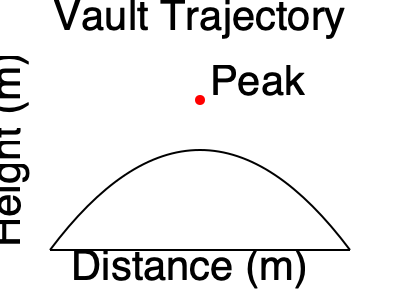As a gymnastics coach, you're analyzing the optimal trajectory for Candice Richer's vault. Assuming the vault follows a parabolic path and neglecting air resistance, what is the initial velocity angle θ (in degrees) that maximizes the horizontal distance traveled if the initial velocity magnitude is 8 m/s and the gymnast takes off at a height of 1.2 m? To find the optimal angle for maximum horizontal distance, we can follow these steps:

1. The equation for the horizontal distance (R) in projectile motion is:
   $$R = \frac{v_0^2}{g} \sin(2\theta) \left(1 + \sqrt{1 + \frac{2gh_0}{v_0^2 \sin^2(\theta)}}\right)$$
   where $v_0$ is the initial velocity, $g$ is the acceleration due to gravity, $\theta$ is the launch angle, and $h_0$ is the initial height.

2. For a flat surface (no initial height), the optimal angle would be 45°. However, with an initial height, the angle is slightly less than 45°.

3. To find the exact angle, we would need to differentiate the equation with respect to θ and set it to zero. However, this leads to a complex equation that's difficult to solve analytically.

4. Instead, we can use the approximation:
   $$\theta_{optimal} \approx 45° - \frac{1}{2} \tan^{-1}\left(\frac{4h_0}{R_0}\right)$$
   where $R_0$ is the range for a flat surface: $R_0 = \frac{v_0^2}{g}$

5. Calculate $R_0$:
   $$R_0 = \frac{(8 \text{ m/s})^2}{9.8 \text{ m/s}^2} = 6.53 \text{ m}$$

6. Now we can calculate the optimal angle:
   $$\theta_{optimal} \approx 45° - \frac{1}{2} \tan^{-1}\left(\frac{4 \cdot 1.2 \text{ m}}{6.53 \text{ m}}\right)$$
   $$\theta_{optimal} \approx 45° - \frac{1}{2} \tan^{-1}(0.735)$$
   $$\theta_{optimal} \approx 45° - 10.1° = 34.9°$$

Therefore, the optimal launch angle is approximately 34.9°.
Answer: 34.9° 